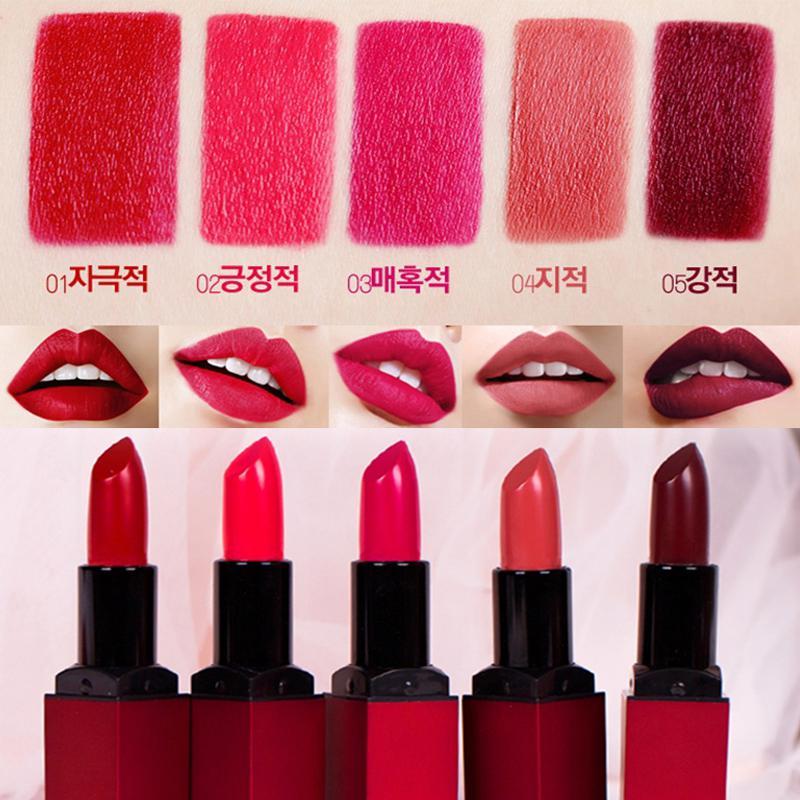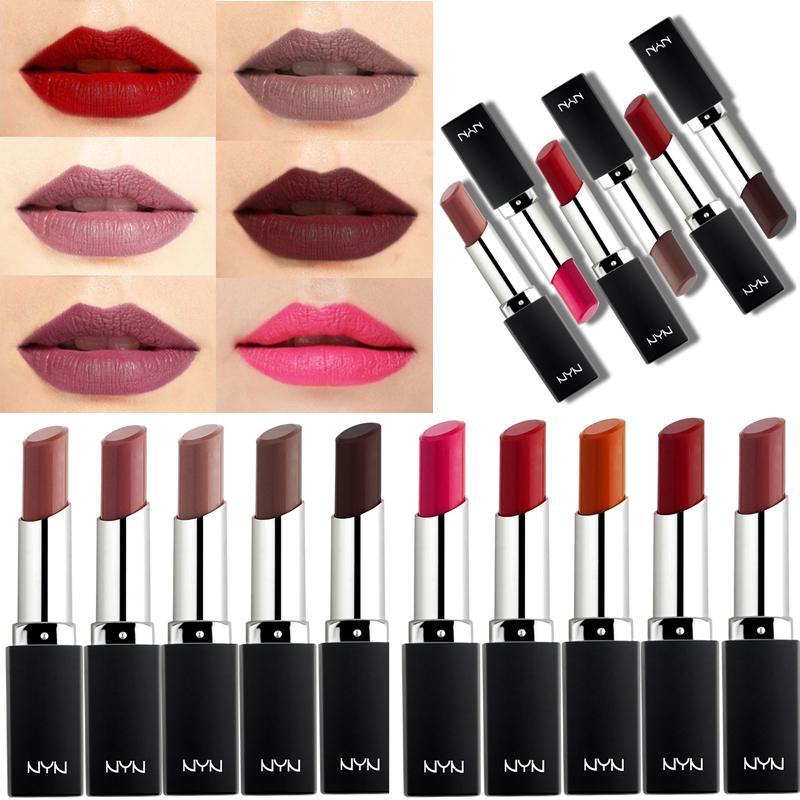The first image is the image on the left, the second image is the image on the right. For the images shown, is this caption "At least one of the images shows exactly three mouths." true? Answer yes or no. No. 